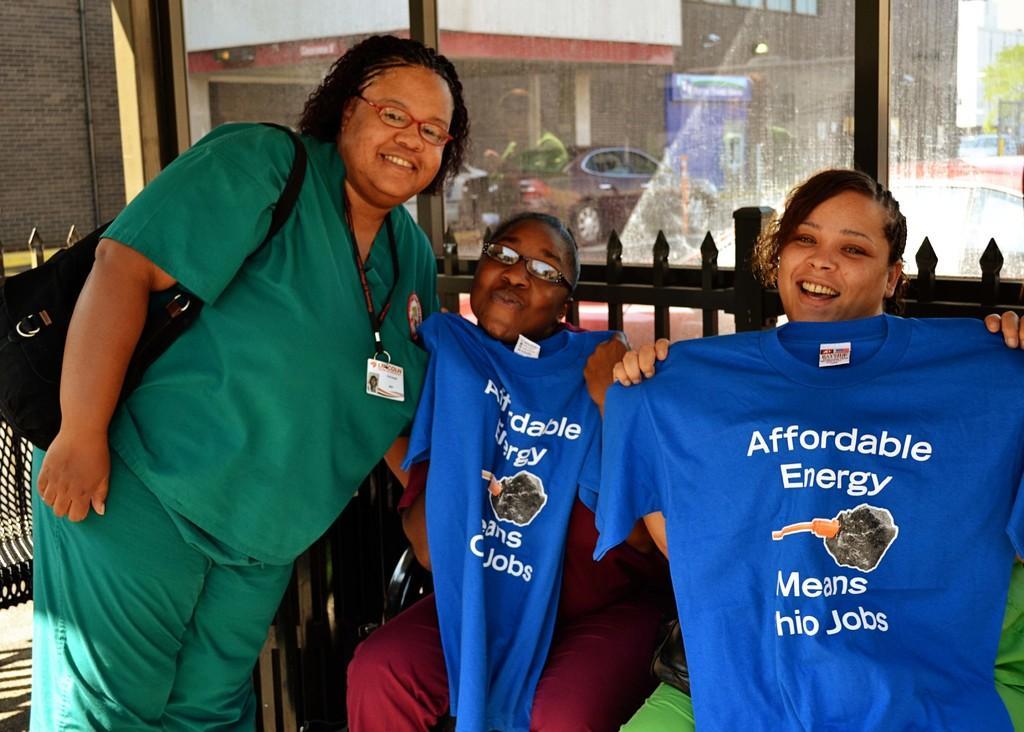In one or two sentences, can you explain what this image depicts? In this image we can see three people, clothes, wall, and glass. Through the glass we can see a car, boards, and a building. 